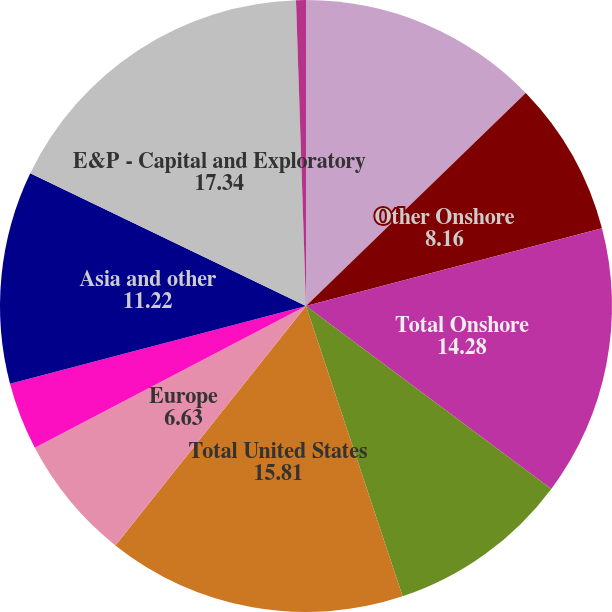Convert chart to OTSL. <chart><loc_0><loc_0><loc_500><loc_500><pie_chart><fcel>Bakken<fcel>Other Onshore<fcel>Total Onshore<fcel>Offshore<fcel>Total United States<fcel>Europe<fcel>Africa<fcel>Asia and other<fcel>E&P - Capital and Exploratory<fcel>United States<nl><fcel>12.75%<fcel>8.16%<fcel>14.28%<fcel>9.69%<fcel>15.81%<fcel>6.63%<fcel>3.58%<fcel>11.22%<fcel>17.34%<fcel>0.52%<nl></chart> 